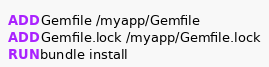Convert code to text. <code><loc_0><loc_0><loc_500><loc_500><_Dockerfile_>ADD Gemfile /myapp/Gemfile
ADD Gemfile.lock /myapp/Gemfile.lock
RUN bundle install
</code> 